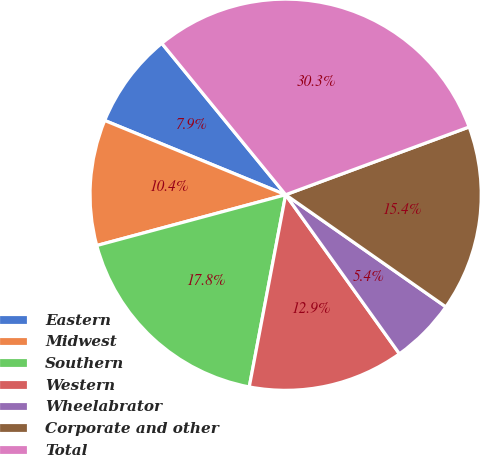Convert chart. <chart><loc_0><loc_0><loc_500><loc_500><pie_chart><fcel>Eastern<fcel>Midwest<fcel>Southern<fcel>Western<fcel>Wheelabrator<fcel>Corporate and other<fcel>Total<nl><fcel>7.89%<fcel>10.38%<fcel>17.84%<fcel>12.86%<fcel>5.4%<fcel>15.35%<fcel>30.28%<nl></chart> 